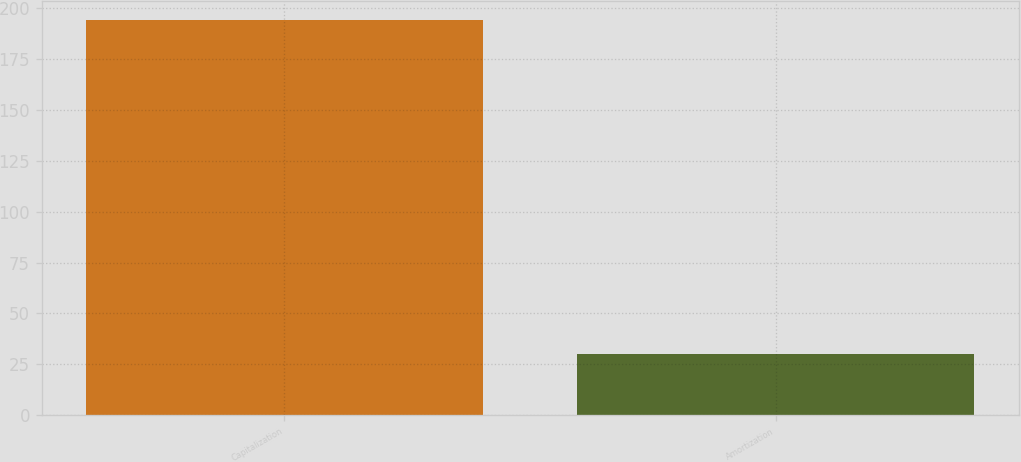Convert chart. <chart><loc_0><loc_0><loc_500><loc_500><bar_chart><fcel>Capitalization<fcel>Amortization<nl><fcel>194<fcel>30<nl></chart> 